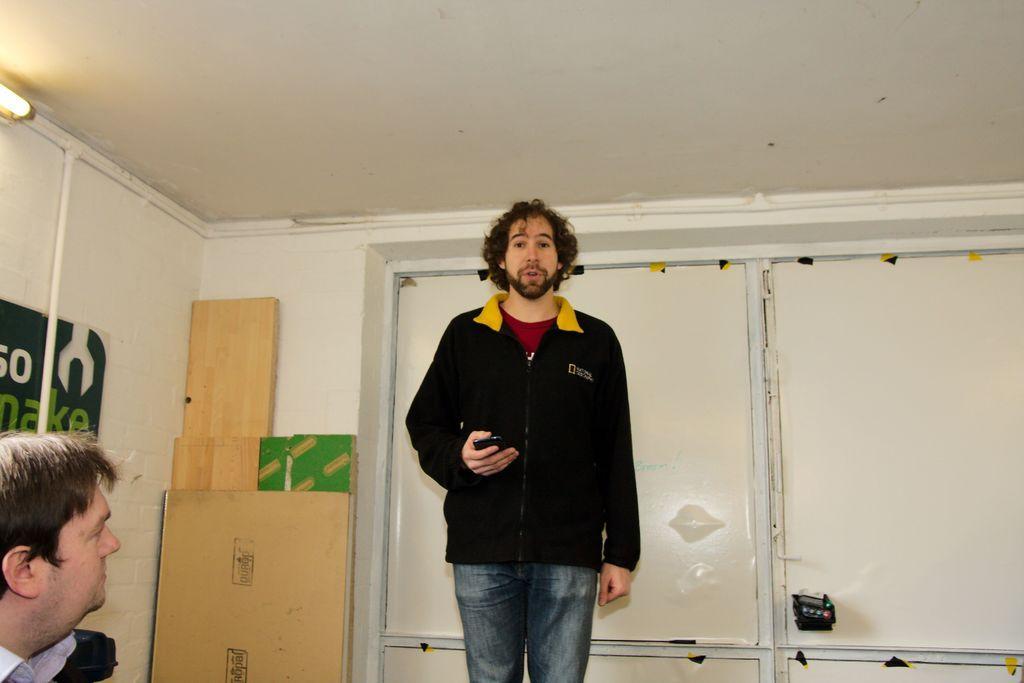Please provide a concise description of this image. In this image, we can see people and one of them is holding a mobile in his hand. In the background, there are cardboards and there is a board with some text and we can see a light, a pipe and a wall. 